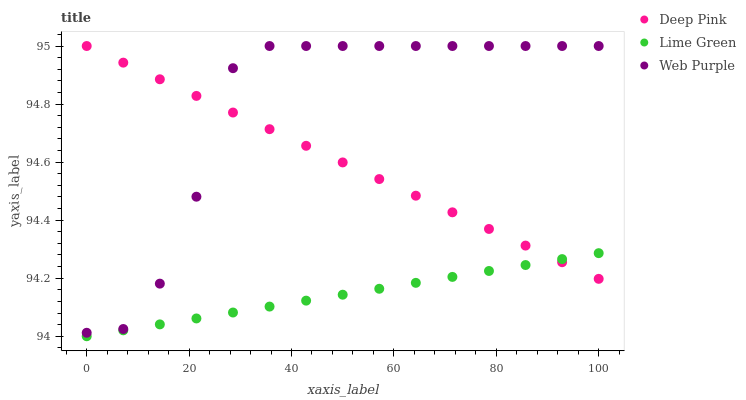Does Lime Green have the minimum area under the curve?
Answer yes or no. Yes. Does Web Purple have the maximum area under the curve?
Answer yes or no. Yes. Does Deep Pink have the minimum area under the curve?
Answer yes or no. No. Does Deep Pink have the maximum area under the curve?
Answer yes or no. No. Is Deep Pink the smoothest?
Answer yes or no. Yes. Is Web Purple the roughest?
Answer yes or no. Yes. Is Lime Green the smoothest?
Answer yes or no. No. Is Lime Green the roughest?
Answer yes or no. No. Does Lime Green have the lowest value?
Answer yes or no. Yes. Does Deep Pink have the lowest value?
Answer yes or no. No. Does Deep Pink have the highest value?
Answer yes or no. Yes. Does Lime Green have the highest value?
Answer yes or no. No. Is Lime Green less than Web Purple?
Answer yes or no. Yes. Is Web Purple greater than Lime Green?
Answer yes or no. Yes. Does Deep Pink intersect Web Purple?
Answer yes or no. Yes. Is Deep Pink less than Web Purple?
Answer yes or no. No. Is Deep Pink greater than Web Purple?
Answer yes or no. No. Does Lime Green intersect Web Purple?
Answer yes or no. No. 